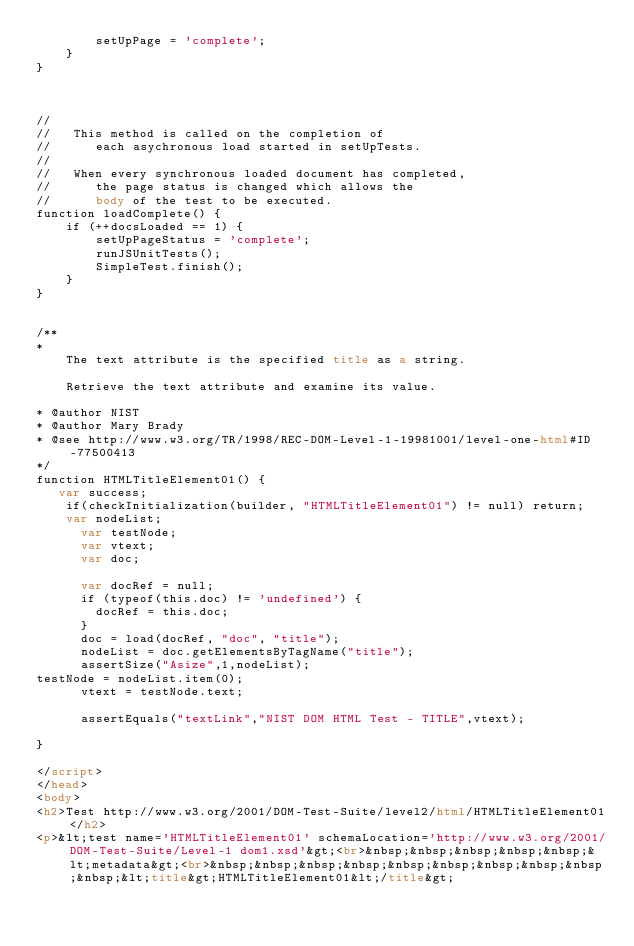<code> <loc_0><loc_0><loc_500><loc_500><_HTML_>        setUpPage = 'complete';
    }
}



//
//   This method is called on the completion of 
//      each asychronous load started in setUpTests.
//
//   When every synchronous loaded document has completed,
//      the page status is changed which allows the
//      body of the test to be executed.
function loadComplete() {
    if (++docsLoaded == 1) {
        setUpPageStatus = 'complete';
        runJSUnitTests();
        SimpleTest.finish();
    }
}


/**
* 
    The text attribute is the specified title as a string.      

    Retrieve the text attribute and examine its value.

* @author NIST
* @author Mary Brady
* @see http://www.w3.org/TR/1998/REC-DOM-Level-1-19981001/level-one-html#ID-77500413
*/
function HTMLTitleElement01() {
   var success;
    if(checkInitialization(builder, "HTMLTitleElement01") != null) return;
    var nodeList;
      var testNode;
      var vtext;
      var doc;
      
      var docRef = null;
      if (typeof(this.doc) != 'undefined') {
        docRef = this.doc;
      }
      doc = load(docRef, "doc", "title");
      nodeList = doc.getElementsByTagName("title");
      assertSize("Asize",1,nodeList);
testNode = nodeList.item(0);
      vtext = testNode.text;

      assertEquals("textLink","NIST DOM HTML Test - TITLE",vtext);
       
}

</script>
</head>
<body>
<h2>Test http://www.w3.org/2001/DOM-Test-Suite/level2/html/HTMLTitleElement01</h2>
<p>&lt;test name='HTMLTitleElement01' schemaLocation='http://www.w3.org/2001/DOM-Test-Suite/Level-1 dom1.xsd'&gt;<br>&nbsp;&nbsp;&nbsp;&nbsp;&nbsp;&lt;metadata&gt;<br>&nbsp;&nbsp;&nbsp;&nbsp;&nbsp;&nbsp;&nbsp;&nbsp;&nbsp;&nbsp;&lt;title&gt;HTMLTitleElement01&lt;/title&gt;</code> 